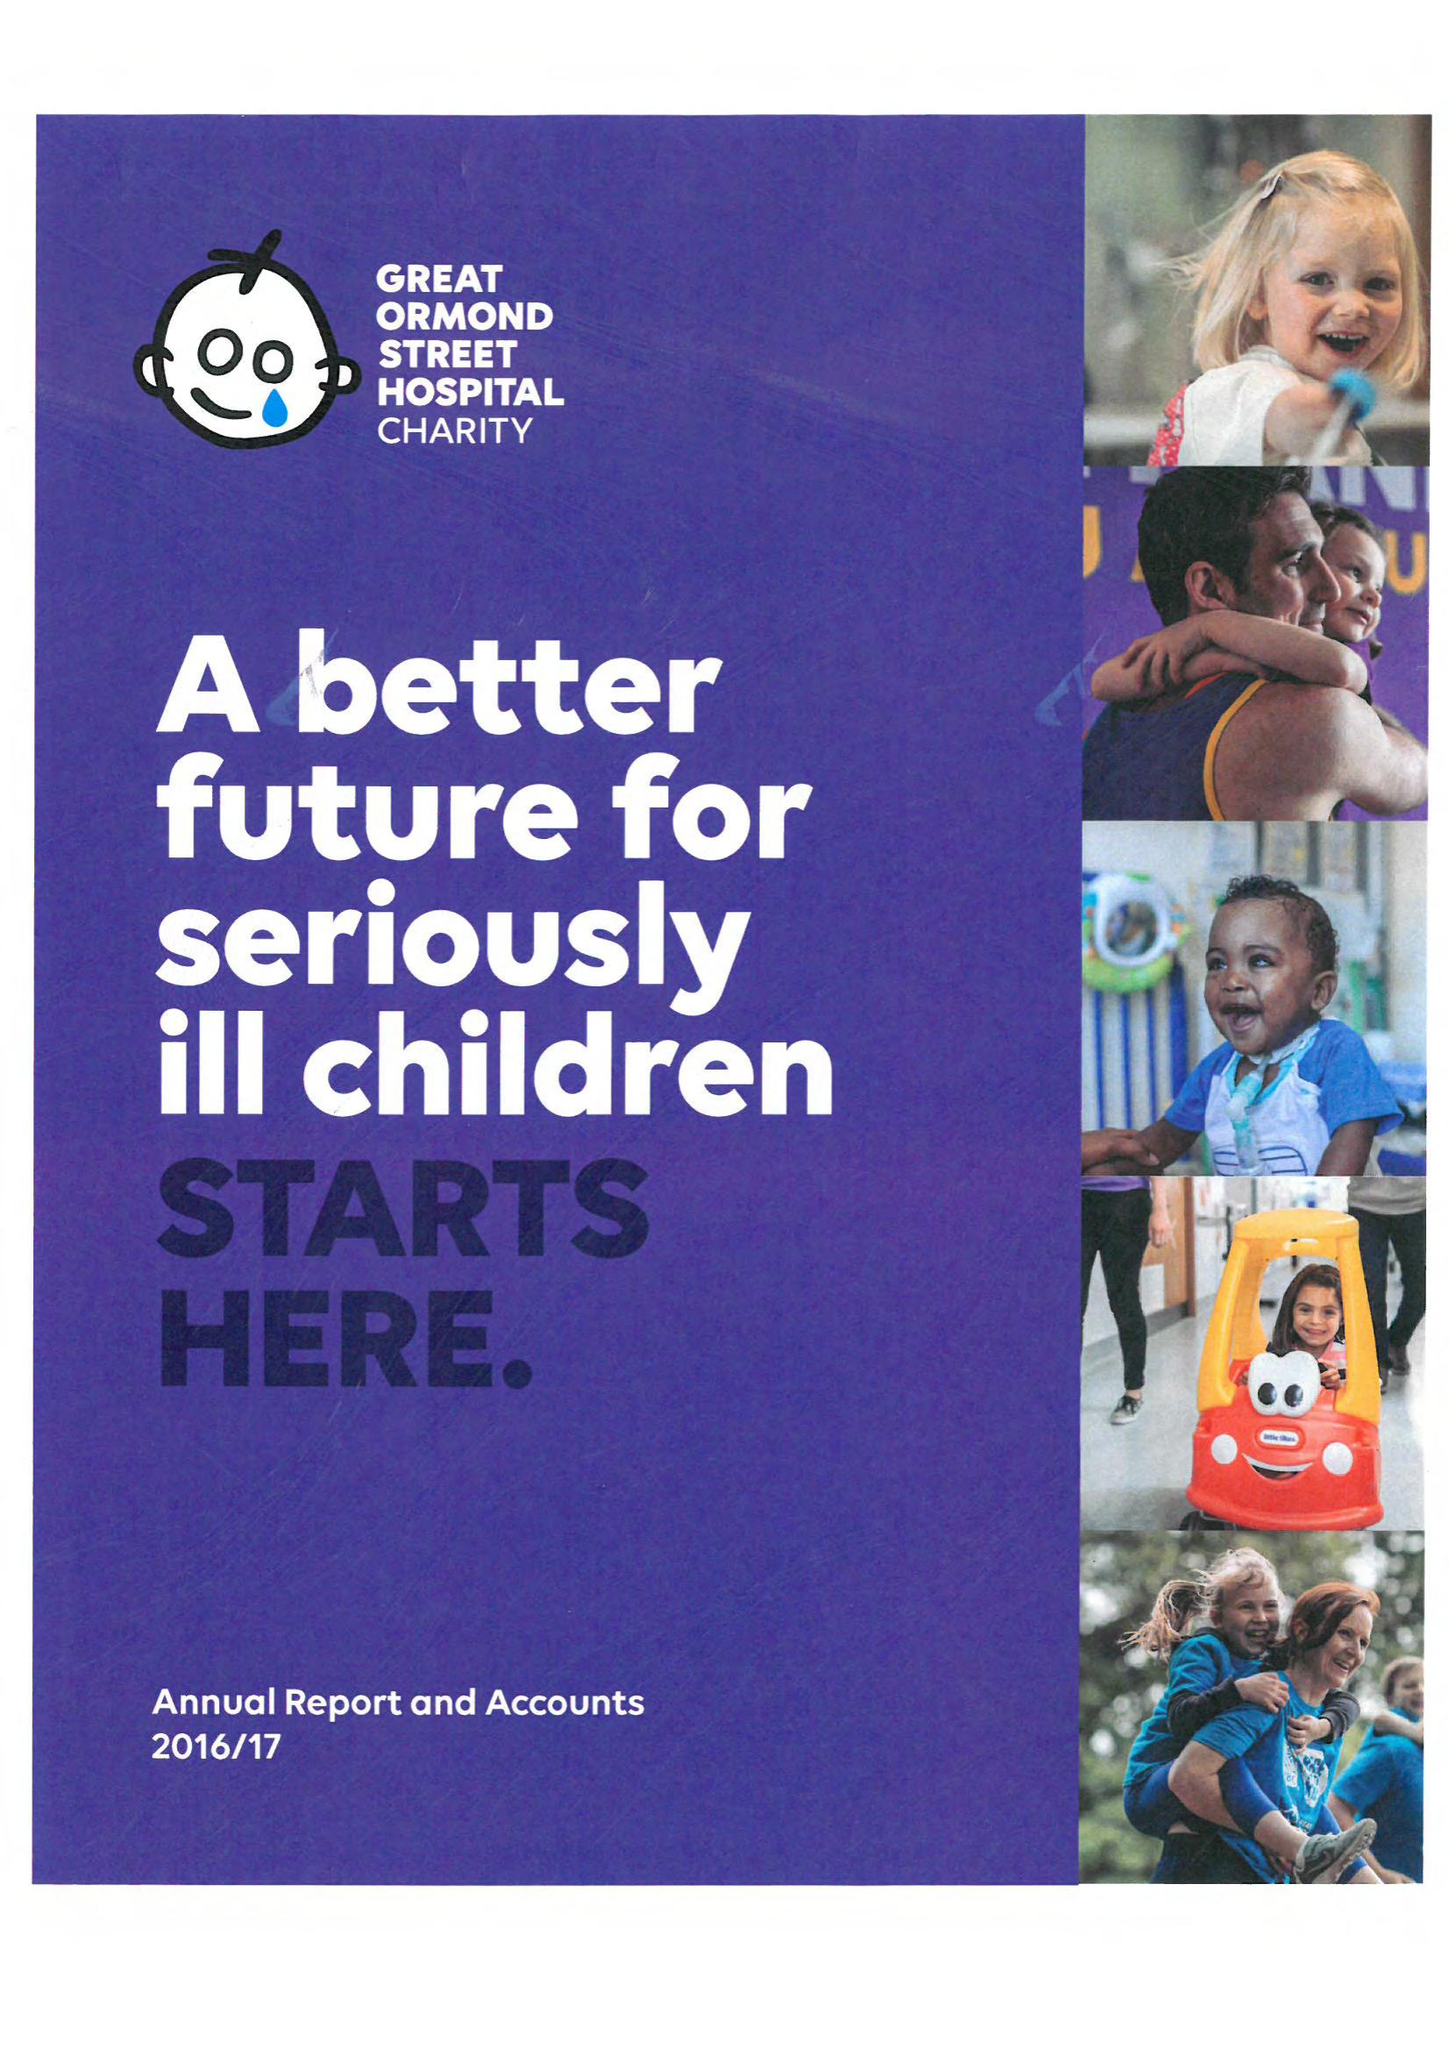What is the value for the report_date?
Answer the question using a single word or phrase. 2017-03-31 